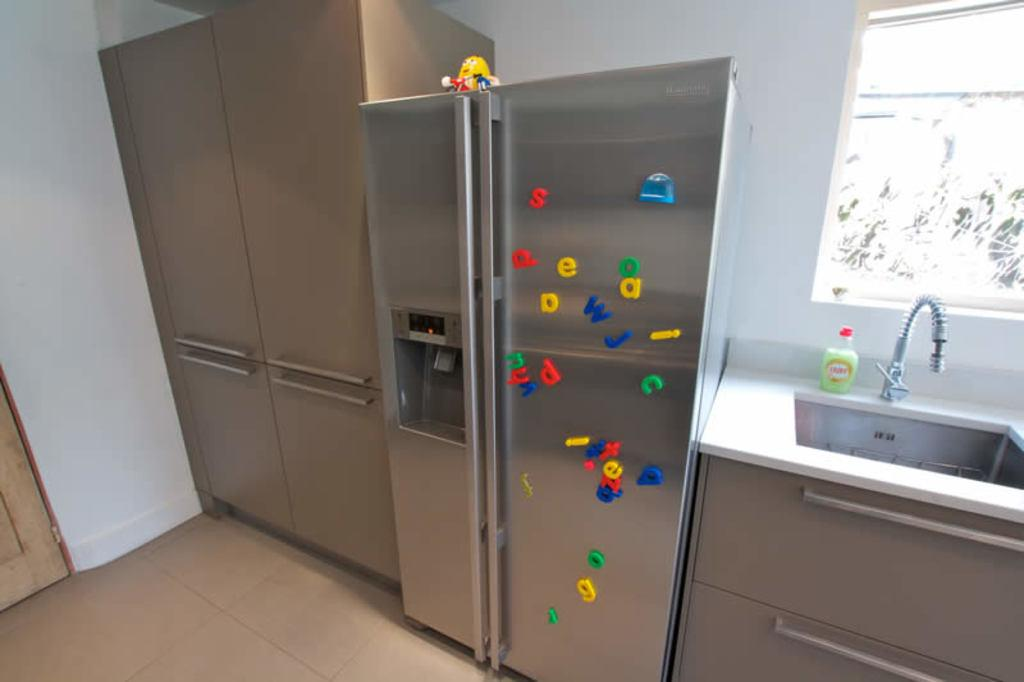<image>
Create a compact narrative representing the image presented. Refrigerator and a kitchen sink that has letters on it. 